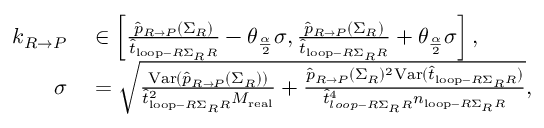Convert formula to latex. <formula><loc_0><loc_0><loc_500><loc_500>\begin{array} { r l } { k _ { R \rightarrow P } } & \in \left [ \frac { \widehat { p } _ { R \rightarrow P } ( \Sigma _ { R } ) } { \widehat { t } _ { l o o p - R \Sigma _ { R } R } } - \theta _ { \frac { \alpha } { 2 } } \sigma , \frac { \widehat { p } _ { R \rightarrow P } ( \Sigma _ { R } ) } { \widehat { t } _ { l o o p - R \Sigma _ { R } R } } + \theta _ { \frac { \alpha } { 2 } } \sigma \right ] , } \\ { \sigma } & = \sqrt { \frac { V a r ( \widehat { p } _ { R \rightarrow P } ( \Sigma _ { R } ) ) } { \widehat { t } _ { l o o p - R \Sigma _ { R } R } ^ { 2 } M _ { r e a l } } + \frac { \widehat { p } _ { R \rightarrow P } ( \Sigma _ { R } ) ^ { 2 } V a r ( \widehat { t } _ { l o o p - R \Sigma _ { R } R } ) } { \widehat { t } _ { l o o p - R \Sigma _ { R } R } ^ { 4 } n _ { l o o p - R \Sigma _ { R } R } } } , } \end{array}</formula> 